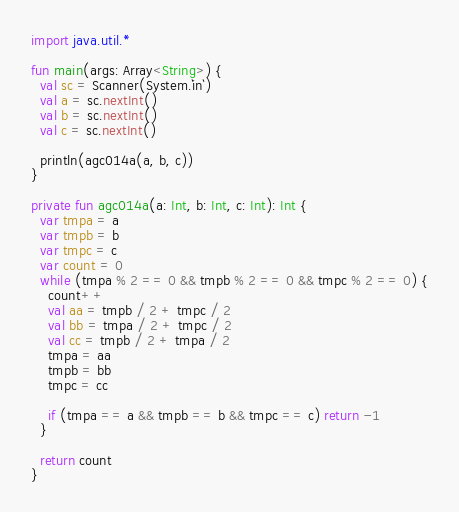Convert code to text. <code><loc_0><loc_0><loc_500><loc_500><_Kotlin_>import java.util.*

fun main(args: Array<String>) {
  val sc = Scanner(System.`in`)
  val a = sc.nextInt()
  val b = sc.nextInt()
  val c = sc.nextInt()

  println(agc014a(a, b, c))
}

private fun agc014a(a: Int, b: Int, c: Int): Int {
  var tmpa = a
  var tmpb = b
  var tmpc = c
  var count = 0
  while (tmpa % 2 == 0 && tmpb % 2 == 0 && tmpc % 2 == 0) {
    count++
    val aa = tmpb / 2 + tmpc / 2
    val bb = tmpa / 2 + tmpc / 2
    val cc = tmpb / 2 + tmpa / 2
    tmpa = aa
    tmpb = bb
    tmpc = cc

    if (tmpa == a && tmpb == b && tmpc == c) return -1
  }

  return count
}
</code> 